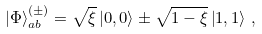<formula> <loc_0><loc_0><loc_500><loc_500>\left | \Phi \right \rangle ^ { ( \pm ) } _ { a b } = \sqrt { \xi } \left | 0 , 0 \right \rangle \pm \sqrt { 1 - \xi } \left | 1 , 1 \right \rangle \, ,</formula> 